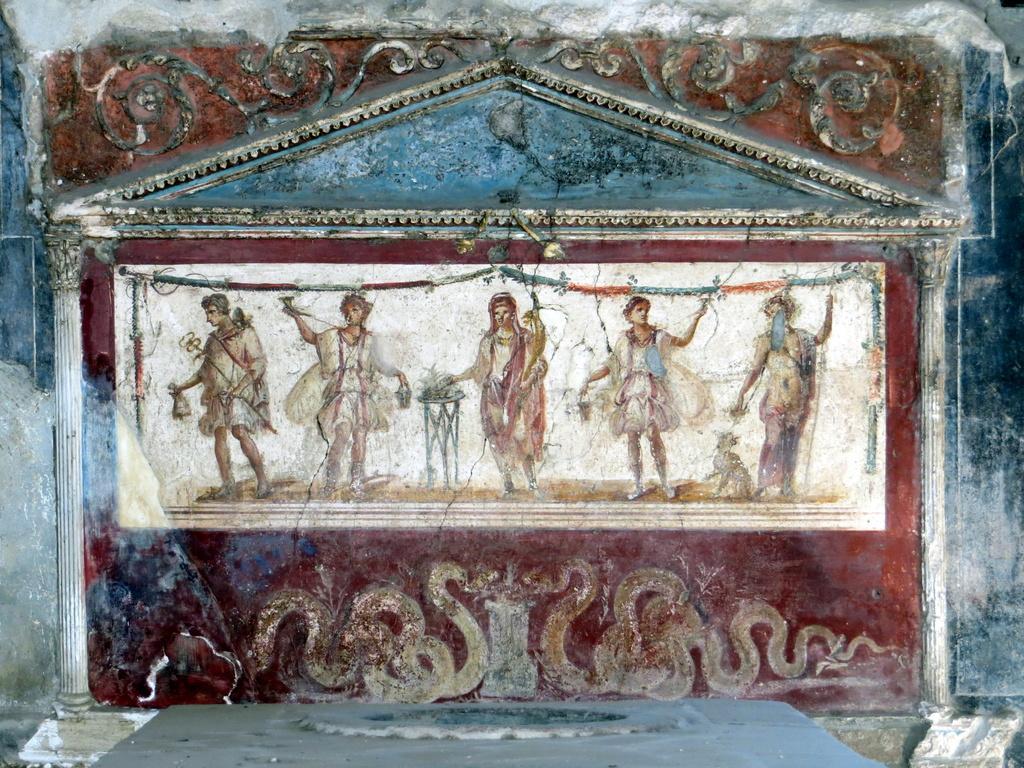Can you describe this image briefly? In this image, this looks like a wall, which is carved. There are five people standing and holding different objects. I think these are the snakes. These look like the pillars. 